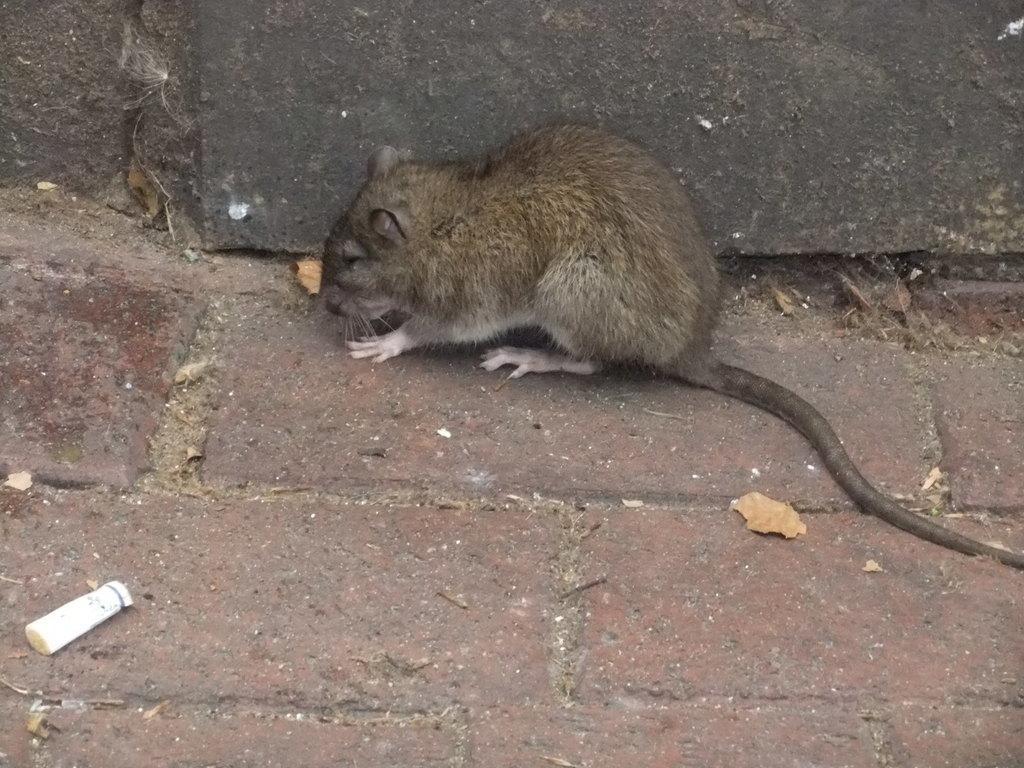What animal is present on the surface in the image? There is a rat on the surface in the image. What type of structure can be seen in the image? There is a wall in the image. Where is the veil located in the image? There is no veil present in the image. What type of shoes can be seen on the rat in the image? There are no shoes present in the image, and the rat is not wearing any. 